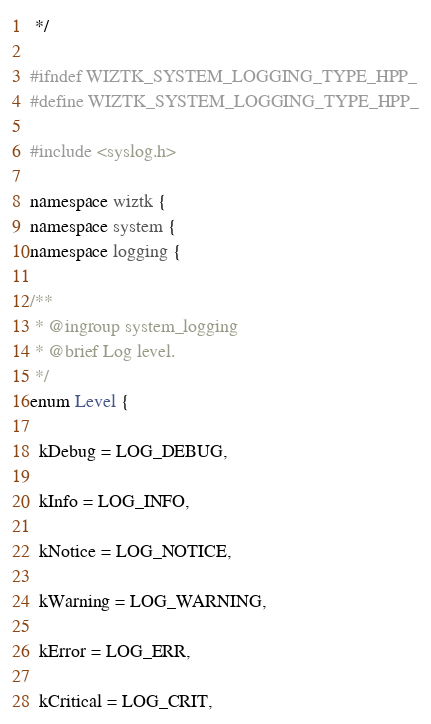<code> <loc_0><loc_0><loc_500><loc_500><_C++_> */

#ifndef WIZTK_SYSTEM_LOGGING_TYPE_HPP_
#define WIZTK_SYSTEM_LOGGING_TYPE_HPP_

#include <syslog.h>

namespace wiztk {
namespace system {
namespace logging {

/**
 * @ingroup system_logging
 * @brief Log level.
 */
enum Level {

  kDebug = LOG_DEBUG,

  kInfo = LOG_INFO,

  kNotice = LOG_NOTICE,

  kWarning = LOG_WARNING,

  kError = LOG_ERR,

  kCritical = LOG_CRIT,
</code> 